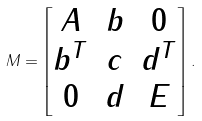<formula> <loc_0><loc_0><loc_500><loc_500>M = \begin{bmatrix} A & b & 0 \\ b ^ { T } & c & d ^ { T } \\ 0 & d & E \end{bmatrix} .</formula> 